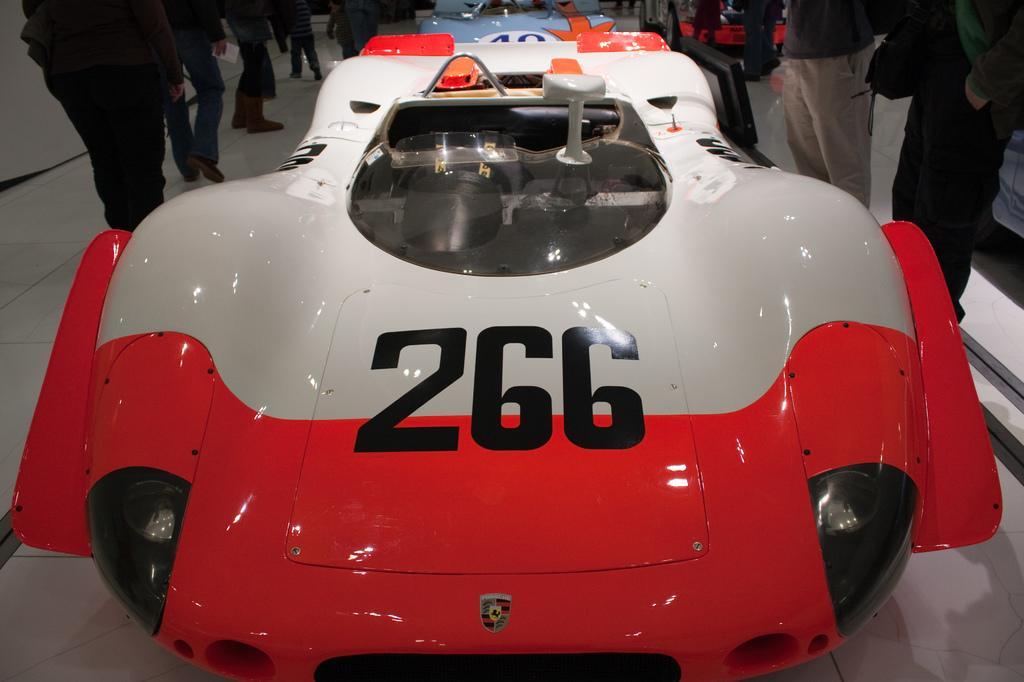Please provide a concise description of this image. In this picture we can see a car in the front, there are some people standing in the background, at the bottom we can see floor. 